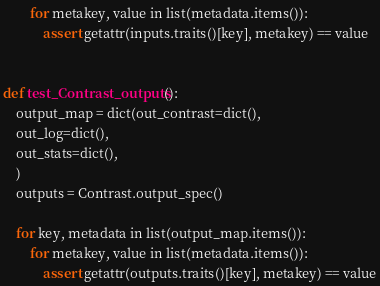<code> <loc_0><loc_0><loc_500><loc_500><_Python_>        for metakey, value in list(metadata.items()):
            assert getattr(inputs.traits()[key], metakey) == value


def test_Contrast_outputs():
    output_map = dict(out_contrast=dict(),
    out_log=dict(),
    out_stats=dict(),
    )
    outputs = Contrast.output_spec()

    for key, metadata in list(output_map.items()):
        for metakey, value in list(metadata.items()):
            assert getattr(outputs.traits()[key], metakey) == value
</code> 